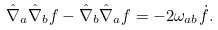<formula> <loc_0><loc_0><loc_500><loc_500>\hat { \nabla } _ { a } \hat { \nabla } _ { b } f - \hat { \nabla } _ { b } \hat { \nabla } _ { a } f = - 2 \omega _ { a b } \dot { f } .</formula> 